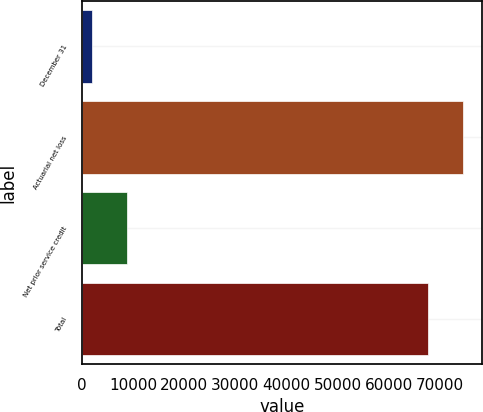Convert chart to OTSL. <chart><loc_0><loc_0><loc_500><loc_500><bar_chart><fcel>December 31<fcel>Actuarial net loss<fcel>Net prior service credit<fcel>Total<nl><fcel>2007<fcel>74425.3<fcel>8806.3<fcel>67626<nl></chart> 